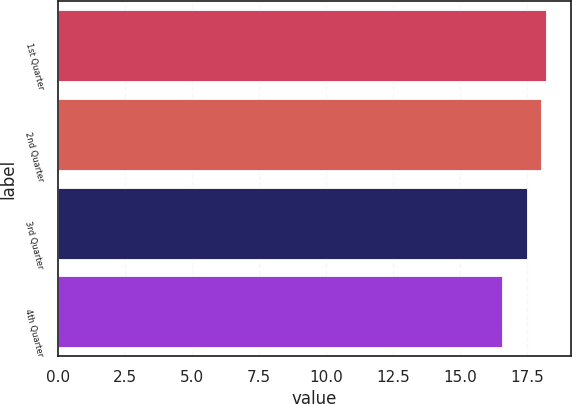Convert chart. <chart><loc_0><loc_0><loc_500><loc_500><bar_chart><fcel>1st Quarter<fcel>2nd Quarter<fcel>3rd Quarter<fcel>4th Quarter<nl><fcel>18.21<fcel>18.01<fcel>17.47<fcel>16.56<nl></chart> 